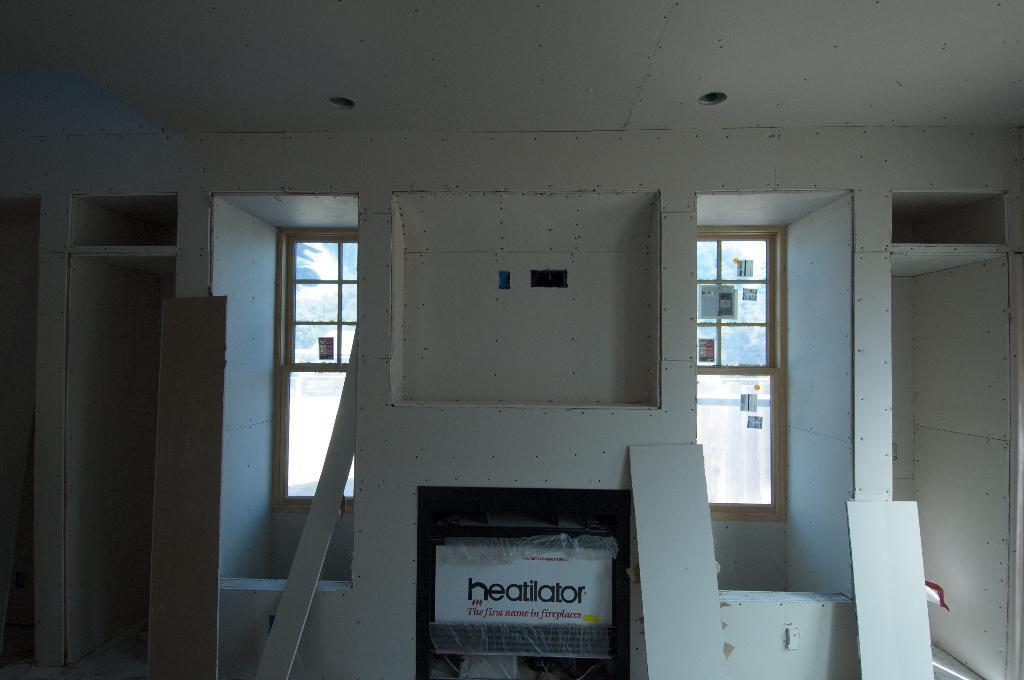Can you describe this image briefly? This picture is clicked inside the room. At the bottom of the picture, we see a board with some text written on it. Behind that, we see a white wall. In the background, we see windows from which we can see trees. We see some stickers are pasted on the window. 